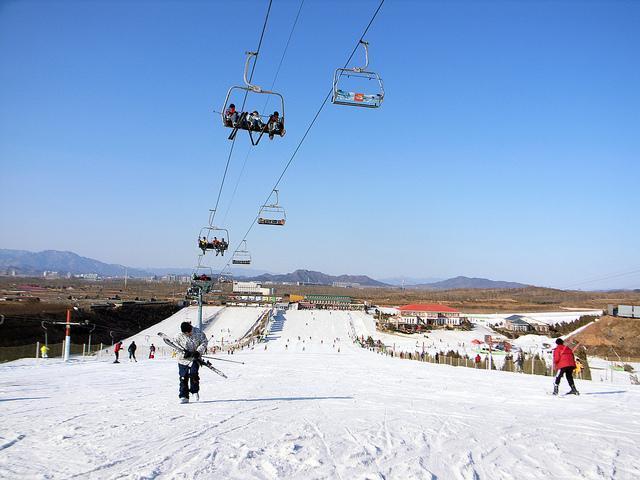How many people are in the picture?
Give a very brief answer. 2. 